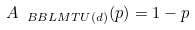Convert formula to latex. <formula><loc_0><loc_0><loc_500><loc_500>A _ { \ B B L M T U ( d ) } ( p ) = 1 - p</formula> 